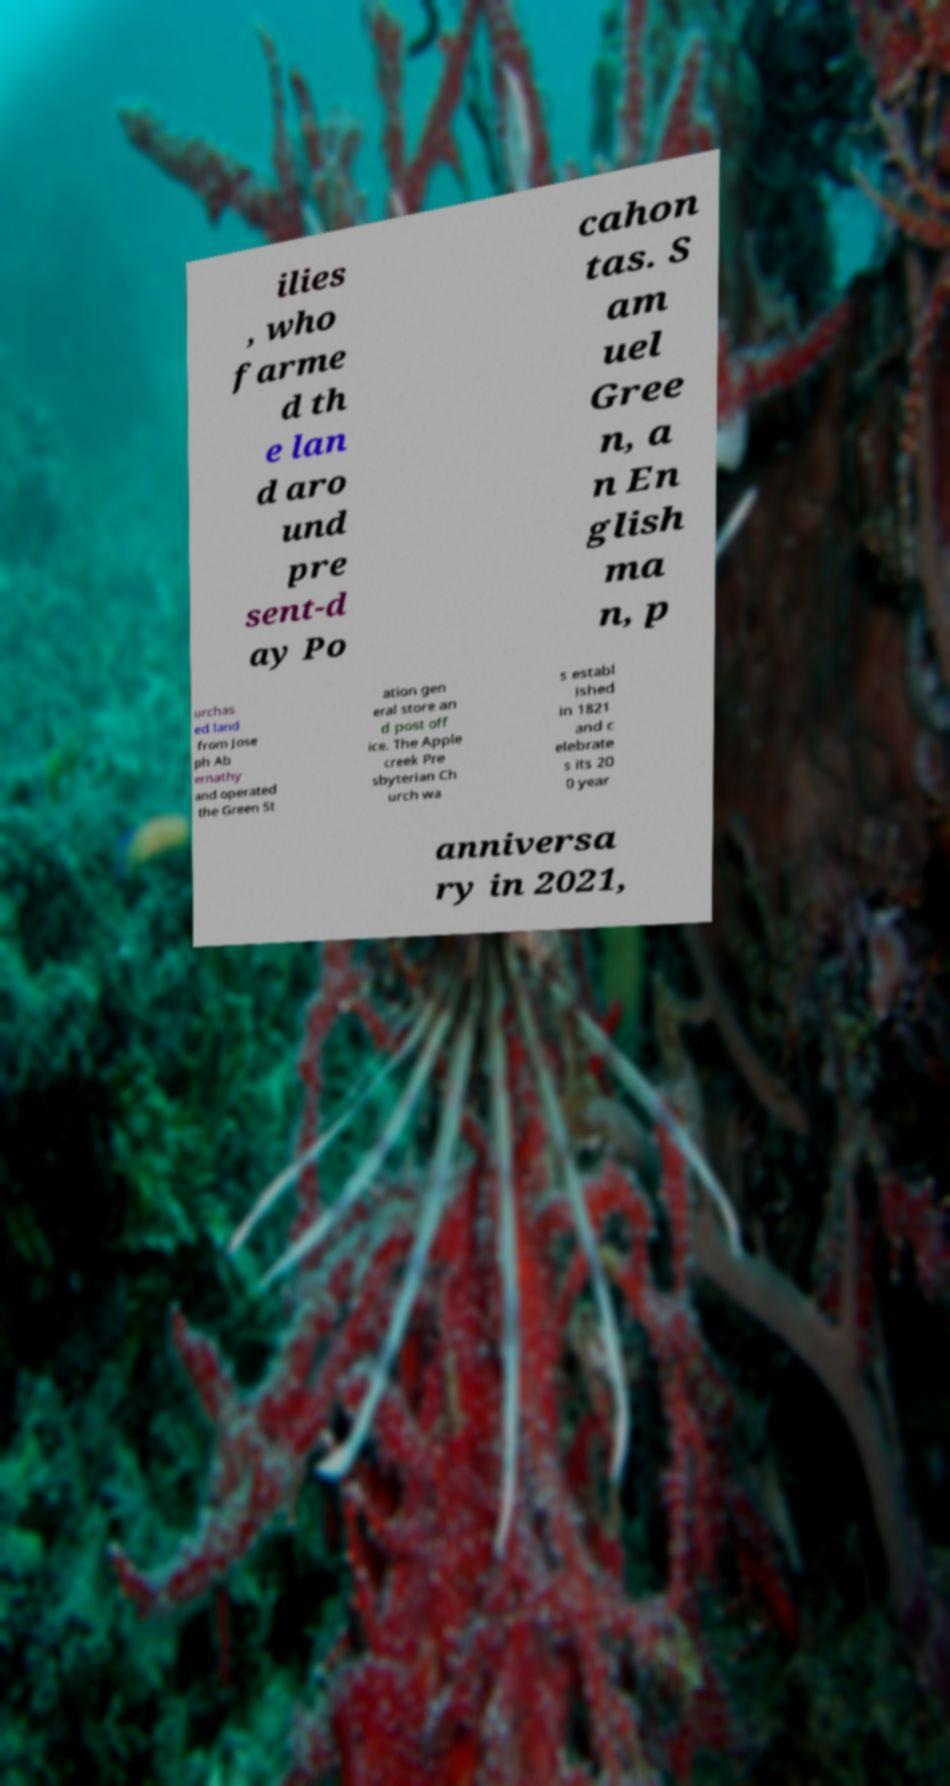Could you assist in decoding the text presented in this image and type it out clearly? ilies , who farme d th e lan d aro und pre sent-d ay Po cahon tas. S am uel Gree n, a n En glish ma n, p urchas ed land from Jose ph Ab ernathy and operated the Green St ation gen eral store an d post off ice. The Apple creek Pre sbyterian Ch urch wa s establ ished in 1821 and c elebrate s its 20 0 year anniversa ry in 2021, 